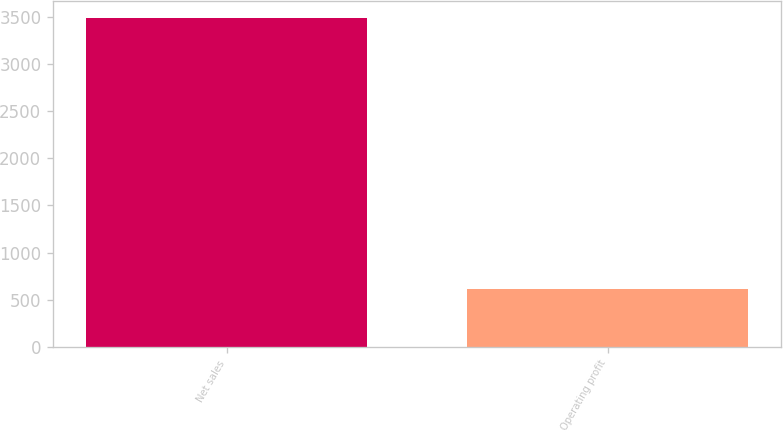Convert chart. <chart><loc_0><loc_0><loc_500><loc_500><bar_chart><fcel>Net sales<fcel>Operating profit<nl><fcel>3489<fcel>611<nl></chart> 